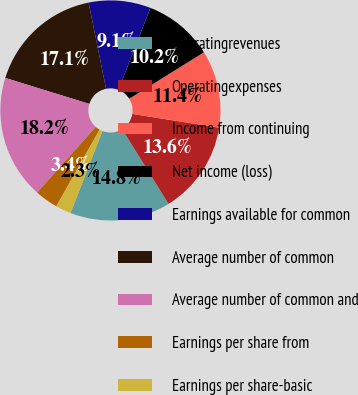<chart> <loc_0><loc_0><loc_500><loc_500><pie_chart><fcel>Operatingrevenues<fcel>Operatingexpenses<fcel>Income from continuing<fcel>Net income (loss)<fcel>Earnings available for common<fcel>Average number of common<fcel>Average number of common and<fcel>Earnings per share from<fcel>Earnings per share-basic<nl><fcel>14.77%<fcel>13.64%<fcel>11.36%<fcel>10.23%<fcel>9.09%<fcel>17.05%<fcel>18.18%<fcel>3.41%<fcel>2.27%<nl></chart> 